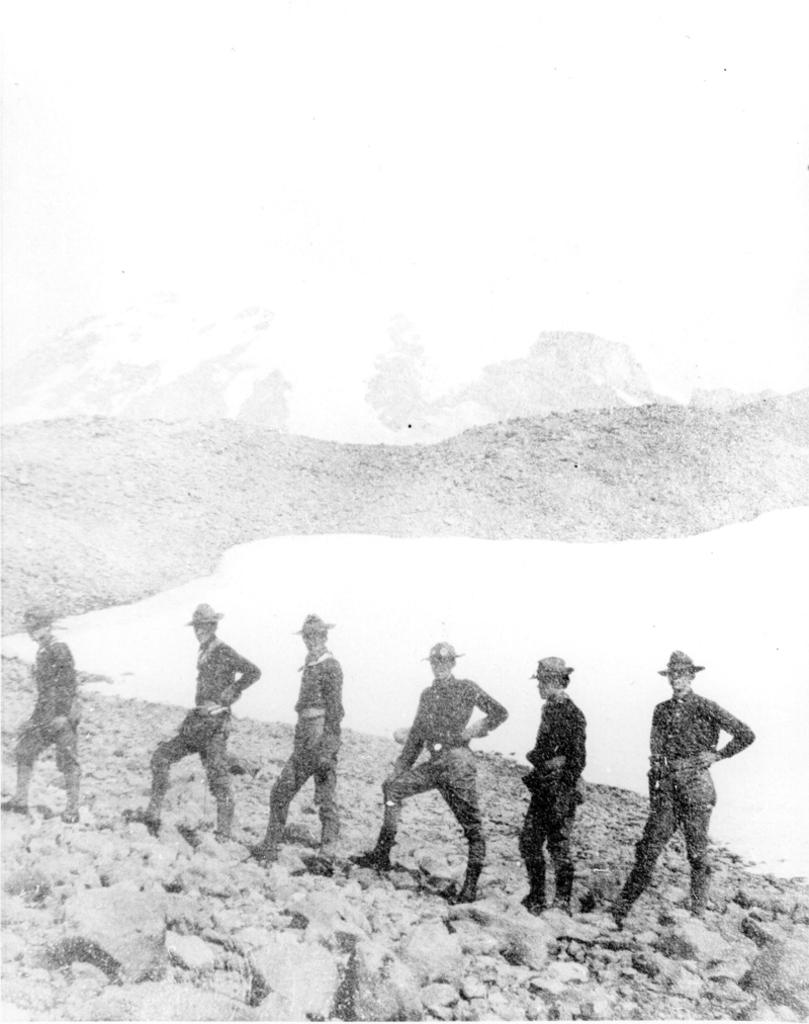What is the color scheme of the image? The image is black and white. Can you describe the age of the image? The image is old. How many men are present in the image? There are six men in the image. What are the men standing on? The men are standing on stones. How are the men arranged in the image? The men are standing in a line. What type of stitch is being used to hold the wire in the image? There is no wire or stitch present in the image. What flavor of soda is being consumed by the men in the image? There is no soda present in the image; the men are standing on stones. 